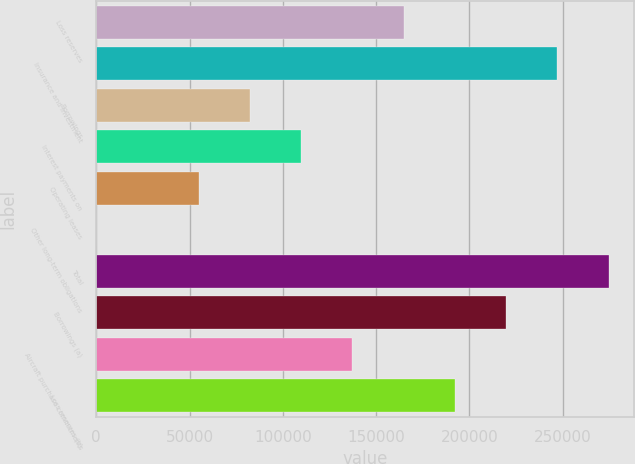Convert chart to OTSL. <chart><loc_0><loc_0><loc_500><loc_500><bar_chart><fcel>Loss reserves<fcel>Insurance and investment<fcel>Borrowings<fcel>Interest payments on<fcel>Operating leases<fcel>Other long-term obligations<fcel>Total<fcel>Borrowings (a)<fcel>Aircraft purchase commitments<fcel>Loss reserves (b)<nl><fcel>164830<fcel>247241<fcel>82417.8<fcel>109888<fcel>54947.2<fcel>6<fcel>274712<fcel>219771<fcel>137359<fcel>192300<nl></chart> 